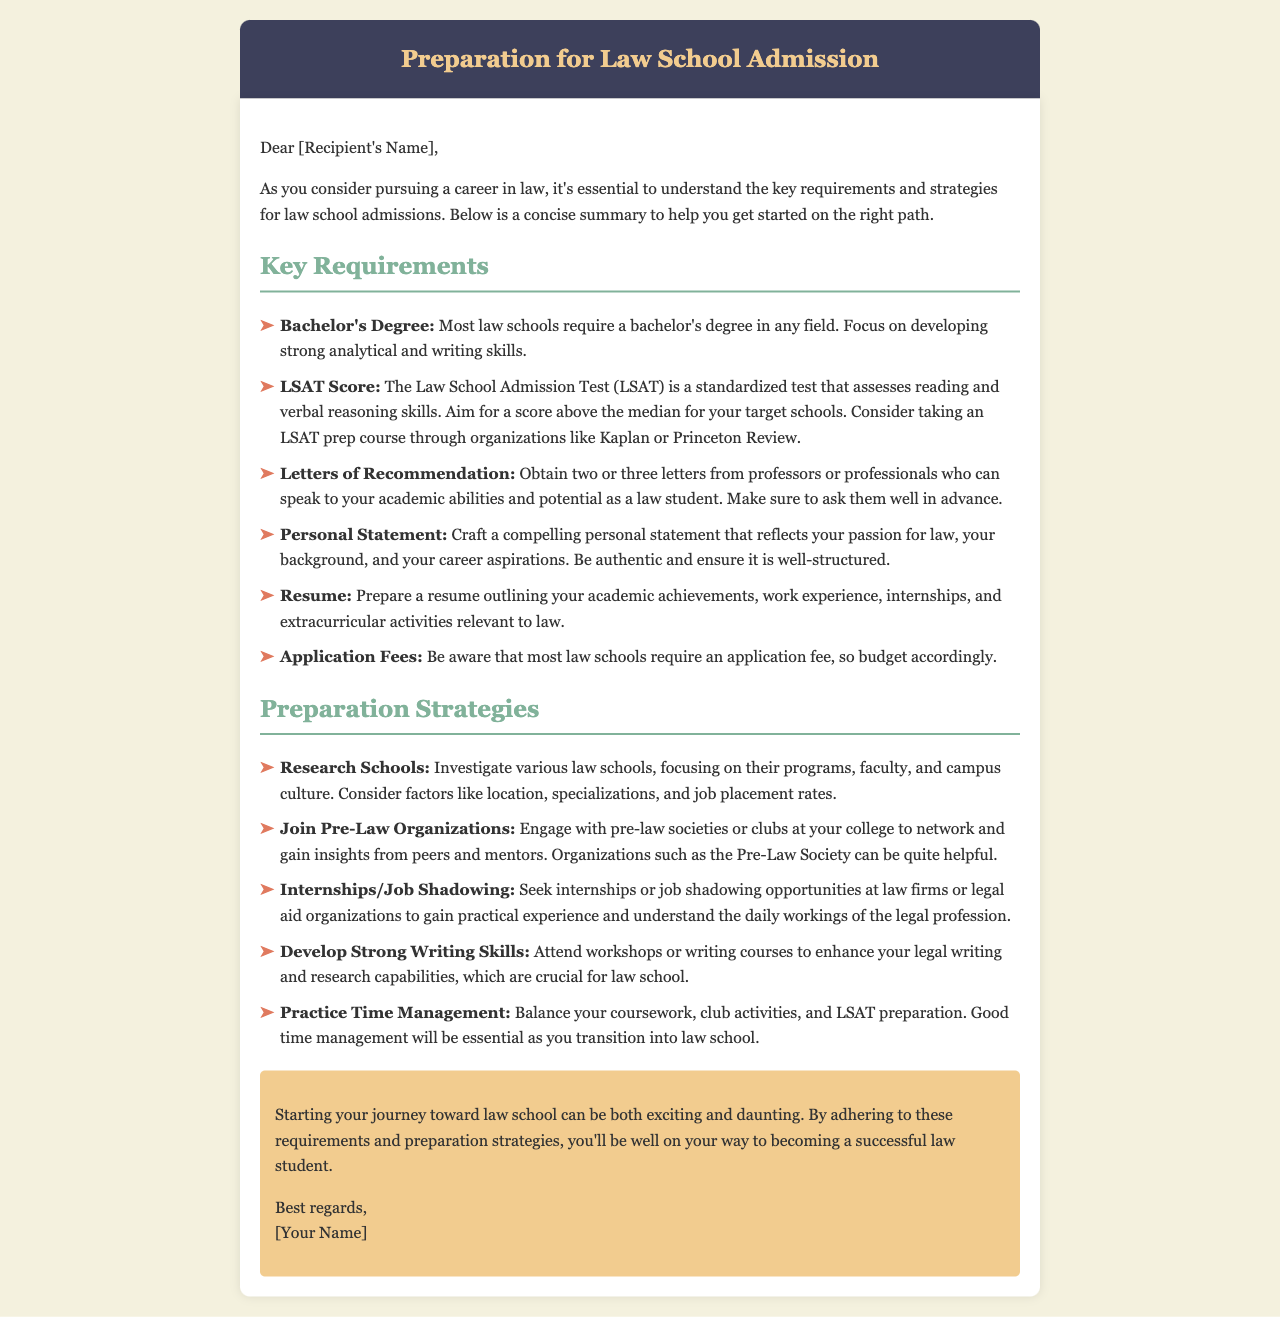What is a common requirement for law schools? Most law schools require a bachelor's degree in any field.
Answer: Bachelor's Degree What test must you take for law school admission? The law school admission process requires taking the LSAT.
Answer: LSAT How many letters of recommendation are typically needed? Obtaining two or three letters from professors or professionals is standard.
Answer: Two or three What score should you aim for on the LSAT? Aim for a score above the median for your target schools.
Answer: Above the median Which organizations are suggested for LSAT preparation? Consider taking an LSAT prep course through organizations like Kaplan or Princeton Review.
Answer: Kaplan or Princeton Review What type of experience should you seek before law school? Seek internships or job shadowing opportunities at law firms or legal aid organizations.
Answer: Internships or job shadowing What is emphasized as an important skill for success in law school? Developing strong writing skills is crucial for law school.
Answer: Writing skills What should you include in your resume for law school applications? Prepare a resume outlining your academic achievements, work experience, internships, and extracurricular activities relevant to law.
Answer: Academic achievements, work experience, internships, extracurricular activities What type of letter will you need to submit? You will need to submit letters of recommendation from professors or professionals.
Answer: Letters of Recommendation What should a personal statement reflect? A compelling personal statement should reflect your passion for law, your background, and your career aspirations.
Answer: Passion for law, background, career aspirations 